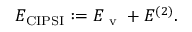<formula> <loc_0><loc_0><loc_500><loc_500>E _ { C I P S I } \colon = E _ { v } + E ^ { ( 2 ) } .</formula> 